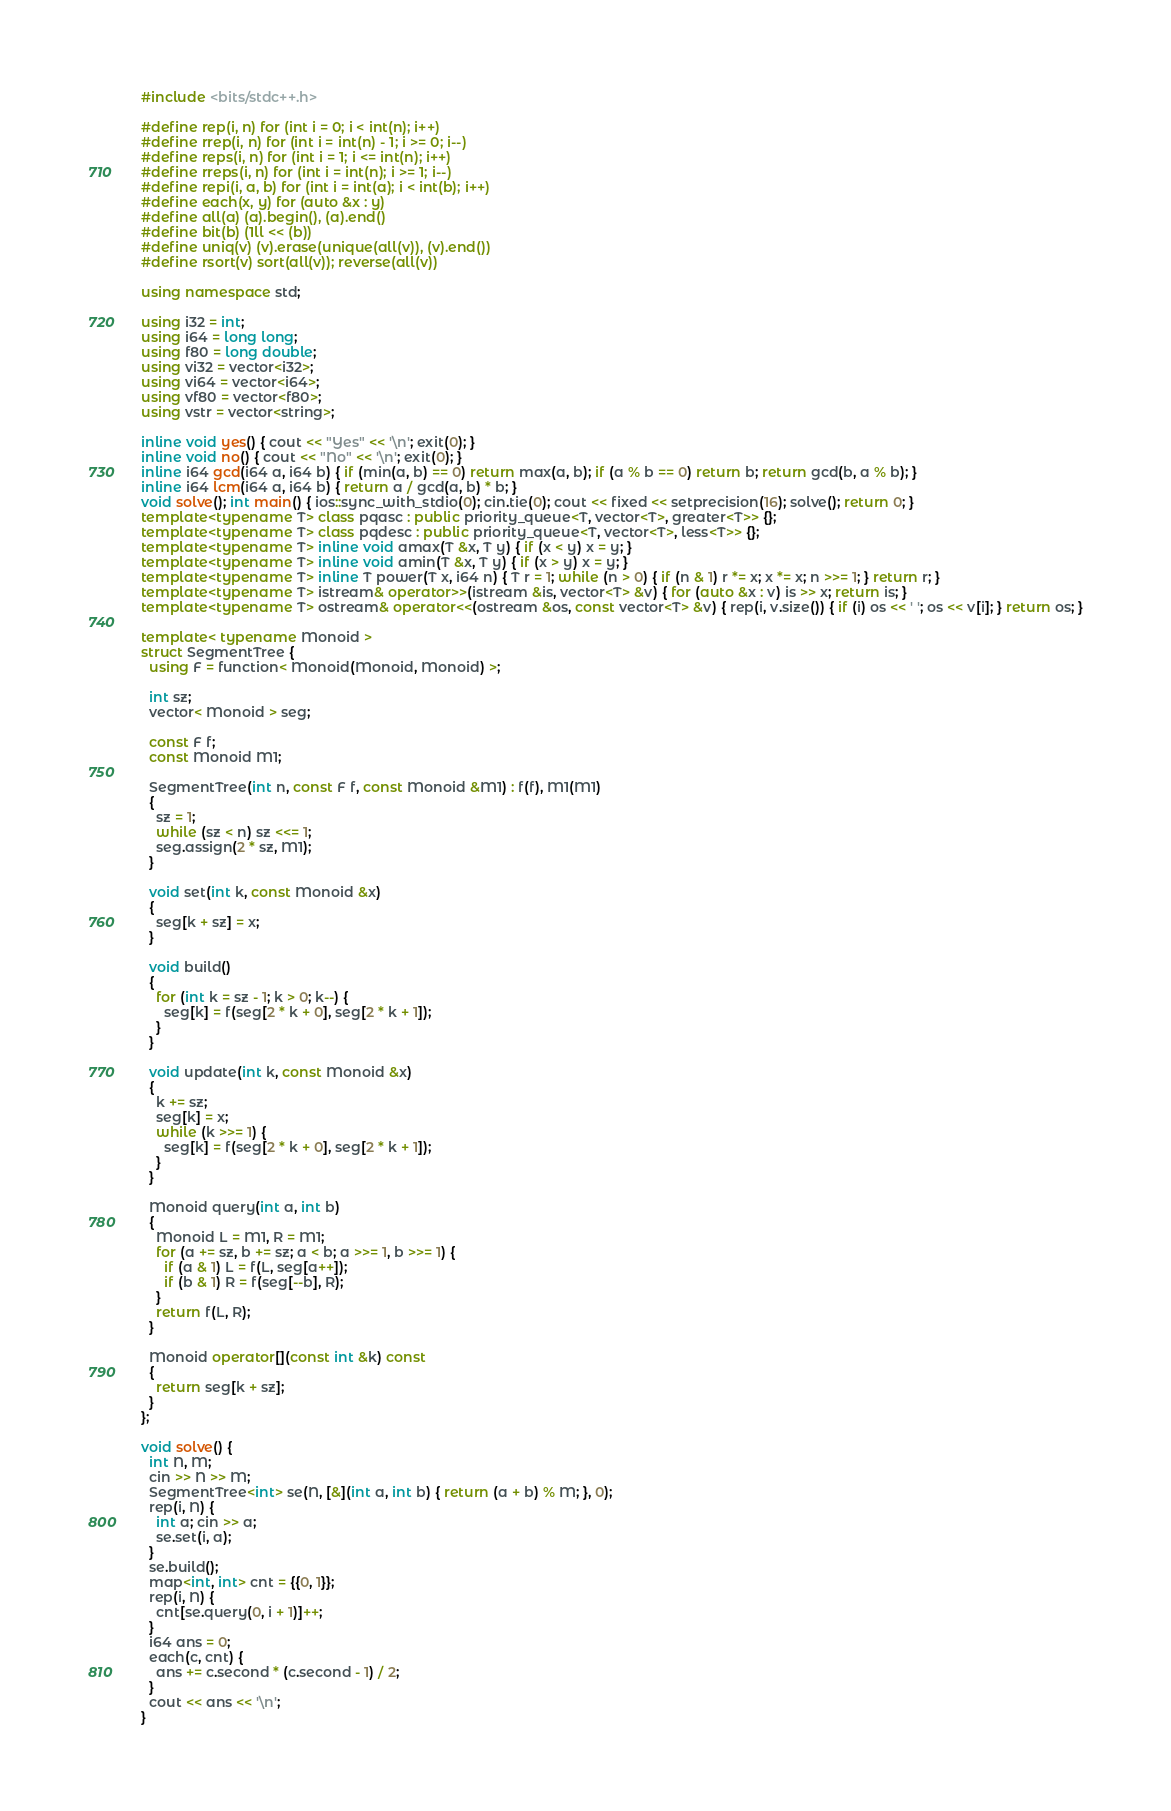Convert code to text. <code><loc_0><loc_0><loc_500><loc_500><_C++_>#include <bits/stdc++.h>

#define rep(i, n) for (int i = 0; i < int(n); i++)
#define rrep(i, n) for (int i = int(n) - 1; i >= 0; i--)
#define reps(i, n) for (int i = 1; i <= int(n); i++)
#define rreps(i, n) for (int i = int(n); i >= 1; i--)
#define repi(i, a, b) for (int i = int(a); i < int(b); i++)
#define each(x, y) for (auto &x : y)
#define all(a) (a).begin(), (a).end()
#define bit(b) (1ll << (b))
#define uniq(v) (v).erase(unique(all(v)), (v).end())
#define rsort(v) sort(all(v)); reverse(all(v))

using namespace std;

using i32 = int;
using i64 = long long;
using f80 = long double;
using vi32 = vector<i32>;
using vi64 = vector<i64>;
using vf80 = vector<f80>;
using vstr = vector<string>;

inline void yes() { cout << "Yes" << '\n'; exit(0); }
inline void no() { cout << "No" << '\n'; exit(0); }
inline i64 gcd(i64 a, i64 b) { if (min(a, b) == 0) return max(a, b); if (a % b == 0) return b; return gcd(b, a % b); }
inline i64 lcm(i64 a, i64 b) { return a / gcd(a, b) * b; }
void solve(); int main() { ios::sync_with_stdio(0); cin.tie(0); cout << fixed << setprecision(16); solve(); return 0; }
template<typename T> class pqasc : public priority_queue<T, vector<T>, greater<T>> {};
template<typename T> class pqdesc : public priority_queue<T, vector<T>, less<T>> {};
template<typename T> inline void amax(T &x, T y) { if (x < y) x = y; }
template<typename T> inline void amin(T &x, T y) { if (x > y) x = y; }
template<typename T> inline T power(T x, i64 n) { T r = 1; while (n > 0) { if (n & 1) r *= x; x *= x; n >>= 1; } return r; }
template<typename T> istream& operator>>(istream &is, vector<T> &v) { for (auto &x : v) is >> x; return is; }
template<typename T> ostream& operator<<(ostream &os, const vector<T> &v) { rep(i, v.size()) { if (i) os << ' '; os << v[i]; } return os; }

template< typename Monoid >
struct SegmentTree {
  using F = function< Monoid(Monoid, Monoid) >;

  int sz;
  vector< Monoid > seg;

  const F f;
  const Monoid M1;

  SegmentTree(int n, const F f, const Monoid &M1) : f(f), M1(M1)
  {
    sz = 1;
    while (sz < n) sz <<= 1;
    seg.assign(2 * sz, M1);
  }

  void set(int k, const Monoid &x)
  {
    seg[k + sz] = x;
  }

  void build()
  {
    for (int k = sz - 1; k > 0; k--) {
      seg[k] = f(seg[2 * k + 0], seg[2 * k + 1]);
    }
  }

  void update(int k, const Monoid &x)
  {
    k += sz;
    seg[k] = x;
    while (k >>= 1) {
      seg[k] = f(seg[2 * k + 0], seg[2 * k + 1]);
    }
  }

  Monoid query(int a, int b)
  {
    Monoid L = M1, R = M1;
    for (a += sz, b += sz; a < b; a >>= 1, b >>= 1) {
      if (a & 1) L = f(L, seg[a++]);
      if (b & 1) R = f(seg[--b], R);
    }
    return f(L, R);
  }

  Monoid operator[](const int &k) const
  {
    return seg[k + sz];
  }
};

void solve() {
  int N, M;
  cin >> N >> M;
  SegmentTree<int> se(N, [&](int a, int b) { return (a + b) % M; }, 0);
  rep(i, N) {
    int a; cin >> a;
    se.set(i, a);
  }
  se.build();
  map<int, int> cnt = {{0, 1}};
  rep(i, N) {
    cnt[se.query(0, i + 1)]++;
  }
  i64 ans = 0;
  each(c, cnt) {
    ans += c.second * (c.second - 1) / 2;
  }
  cout << ans << '\n';
}
</code> 